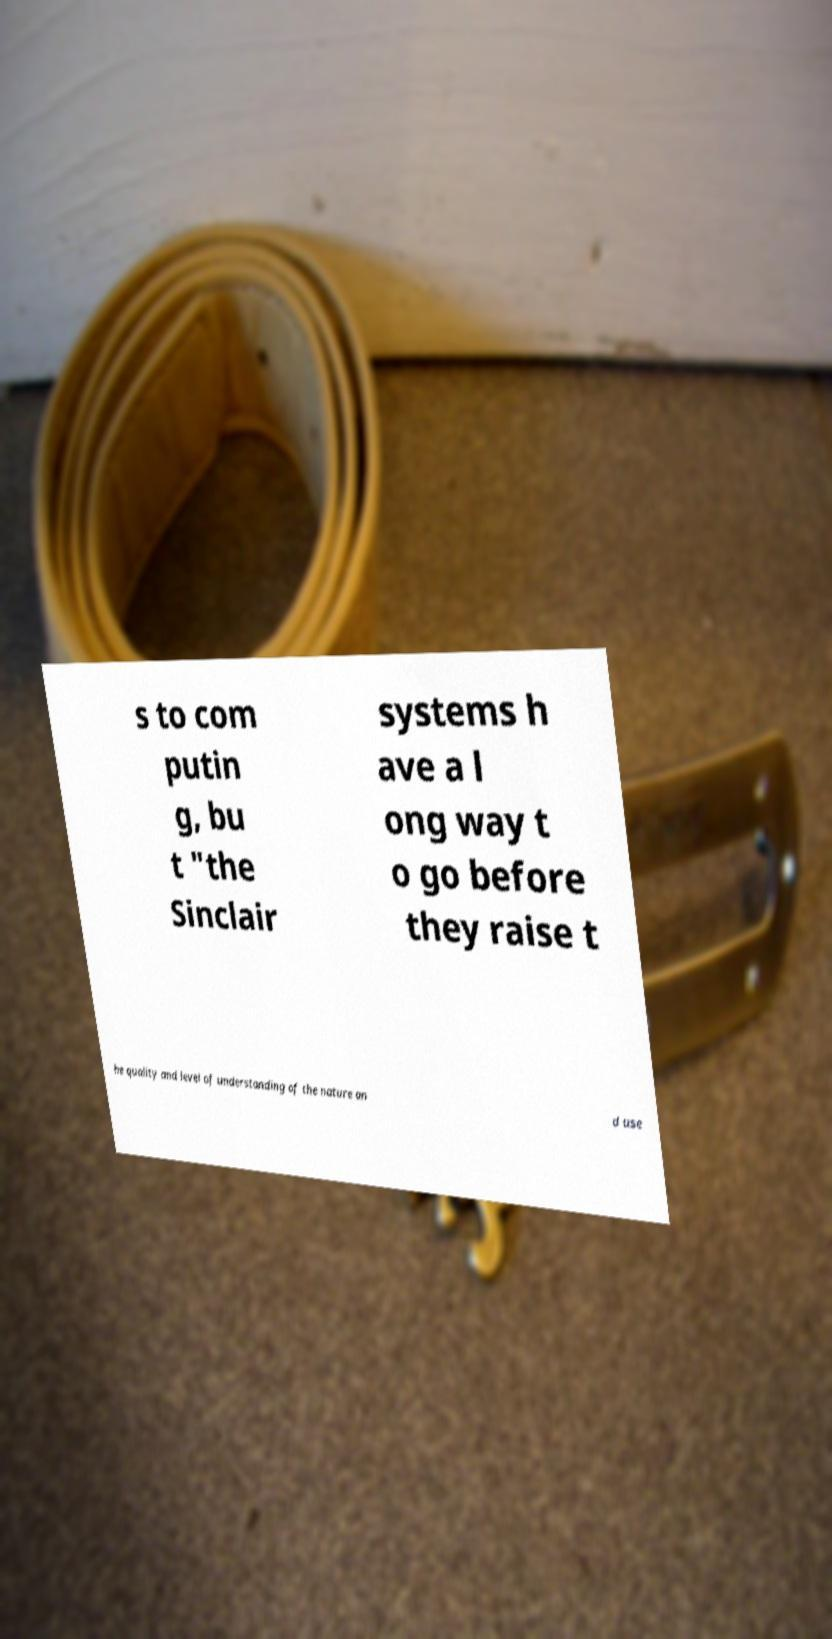Could you extract and type out the text from this image? s to com putin g, bu t "the Sinclair systems h ave a l ong way t o go before they raise t he quality and level of understanding of the nature an d use 